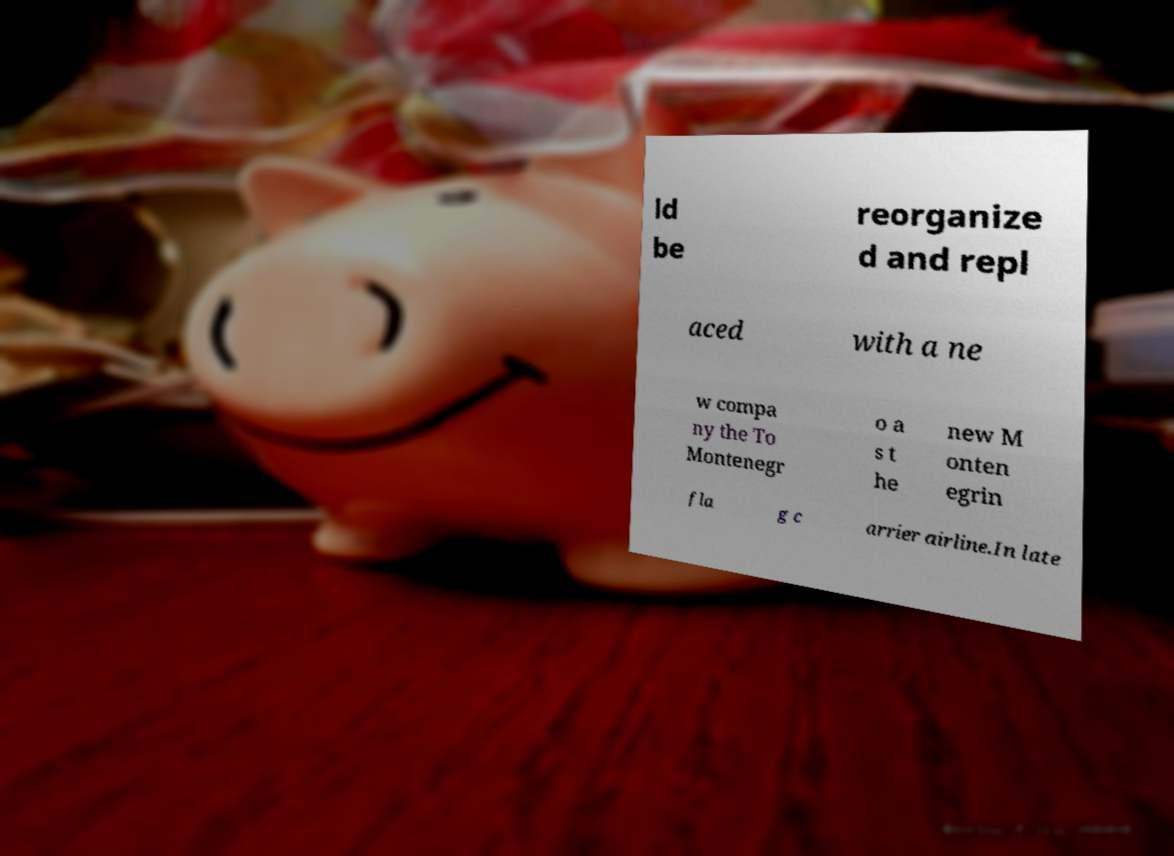There's text embedded in this image that I need extracted. Can you transcribe it verbatim? ld be reorganize d and repl aced with a ne w compa ny the To Montenegr o a s t he new M onten egrin fla g c arrier airline.In late 